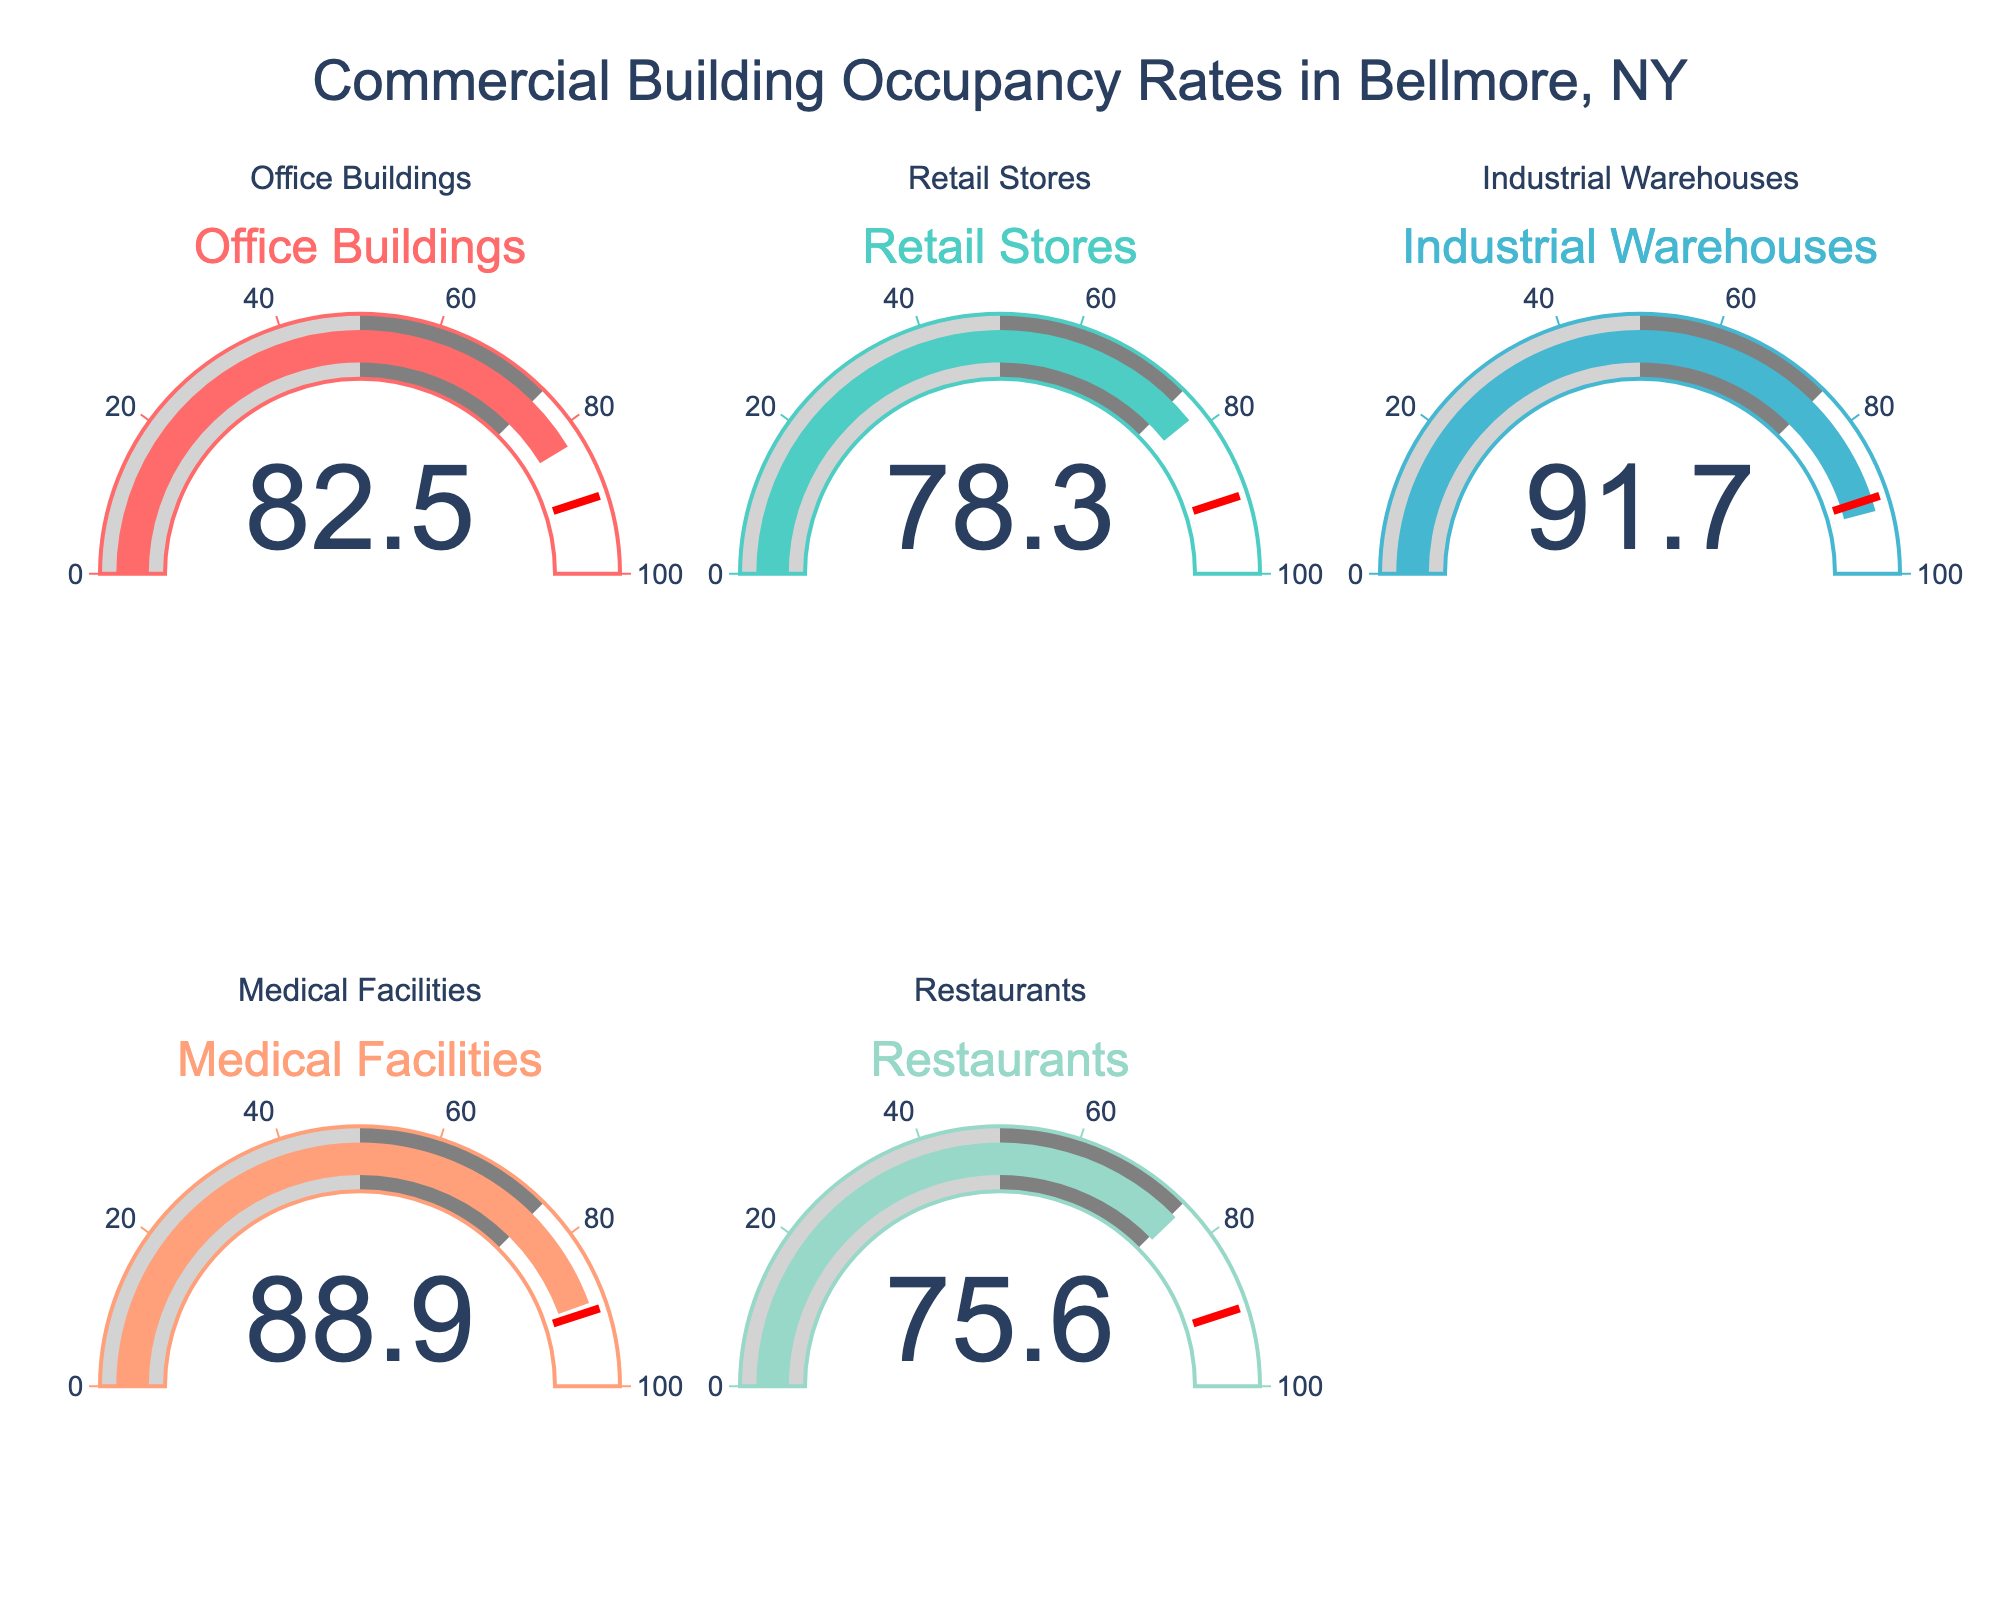What is the occupancy rate of Retail Stores? According to the gauge chart, the occupancy rate for Retail Stores is presented at the value 78.3.
Answer: 78.3 Which type of building has the highest occupancy rate? By observing the gauges, Industrial Warehouses have the highest occupancy rate with a value of 91.7.
Answer: Industrial Warehouses What is the average occupancy rate across all building types? Sum the occupancy rates (82.5 + 78.3 + 91.7 + 88.9 + 75.6) = 417, then divide by the number of building types (5). The average is 417/5 = 83.4.
Answer: 83.4 How much greater is the occupancy rate of Medical Facilities compared to Restaurants? The occupancy rate for Medical Facilities is 88.9, and for Restaurants, it's 75.6. The difference is 88.9 - 75.6 = 13.3.
Answer: 13.3 Which building type has the lowest occupancy rate, and what is the value? Observing the gauges, the Restaurants have the lowest occupancy rate with a value of 75.6.
Answer: Restaurants, 75.6 Is the occupancy rate of Industrial Warehouses above or below the 90 threshold indicated in the gauge? The occupancy rate for Industrial Warehouses is 91.7, which is above the 90 threshold.
Answer: Above What is the combined occupancy rate for Office Buildings and Medical Facilities? Adding the occupancy rates (82.5 for Office Buildings and 88.9 for Medical Facilities), we get 82.5 + 88.9 = 171.4.
Answer: 171.4 How does the occupancy rate of Office Buildings compare to that of Medical Facilities? The occupancy rate for Office Buildings is 82.5, and for Medical Facilities, it is 88.9. Thus, Medical Facilities have a higher occupancy rate than Office Buildings.
Answer: Medical Facilities have a higher rate Which two building types have occupancy rates closest to each other? Comparing the values: Office Buildings (82.5) and Retail Stores (78.3) have a 4.2 difference; Retail Stores (78.3) and Restaurants (75.6) have a 2.7 difference; Medical Facilities (88.9) and Industrial Warehouses (91.7) have a 2.8 difference. The closest rates are Retail Stores and Restaurants with a difference of 2.7.
Answer: Retail Stores and Restaurants 